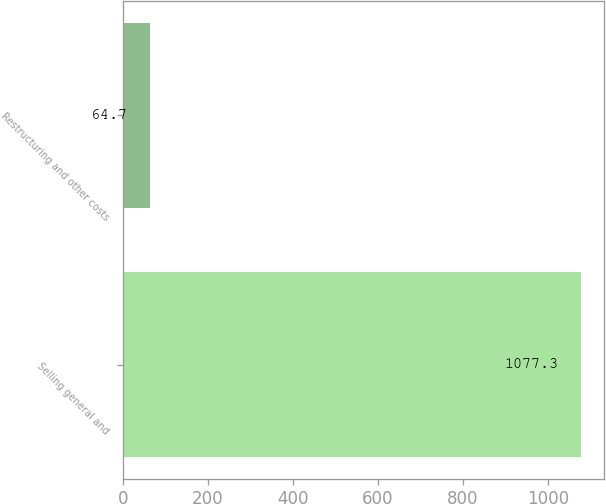Convert chart to OTSL. <chart><loc_0><loc_0><loc_500><loc_500><bar_chart><fcel>Selling general and<fcel>Restructuring and other costs<nl><fcel>1077.3<fcel>64.7<nl></chart> 